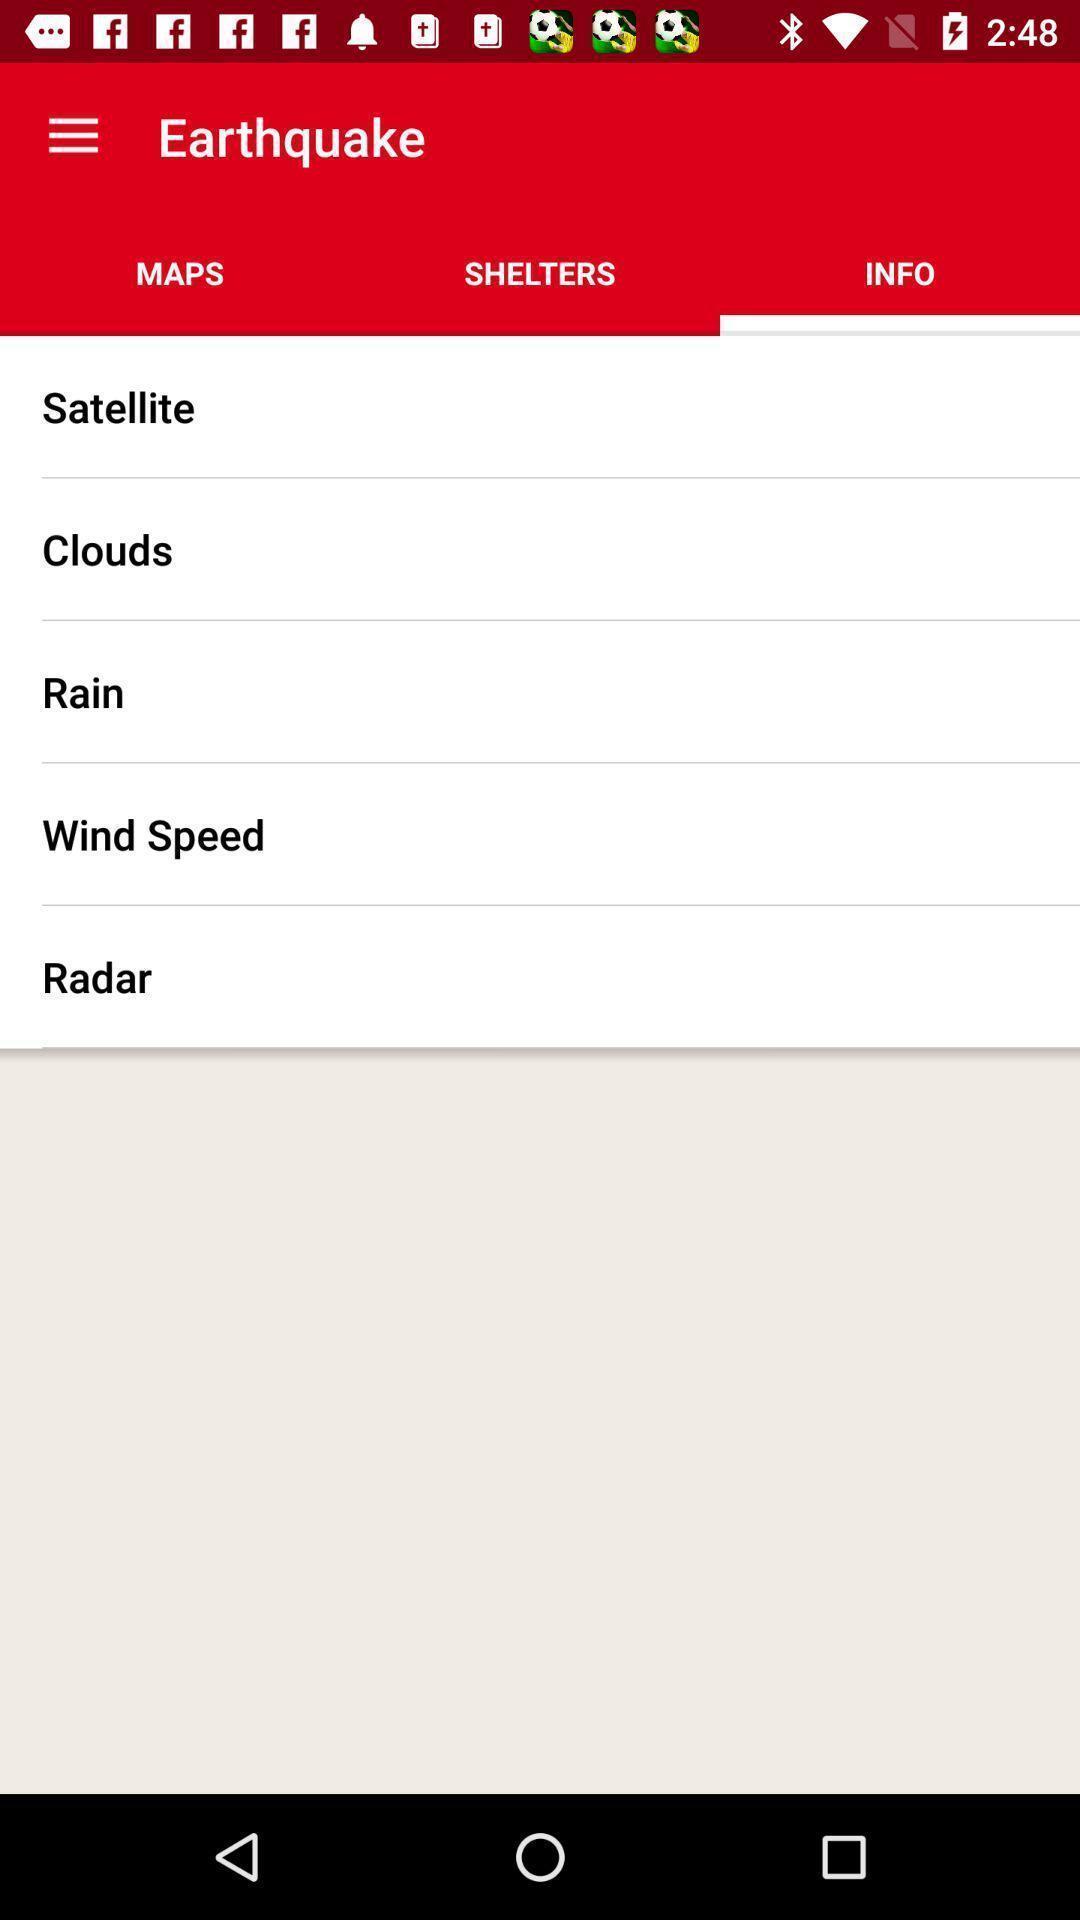Provide a description of this screenshot. Page displays list of information about natural calamities in app. 